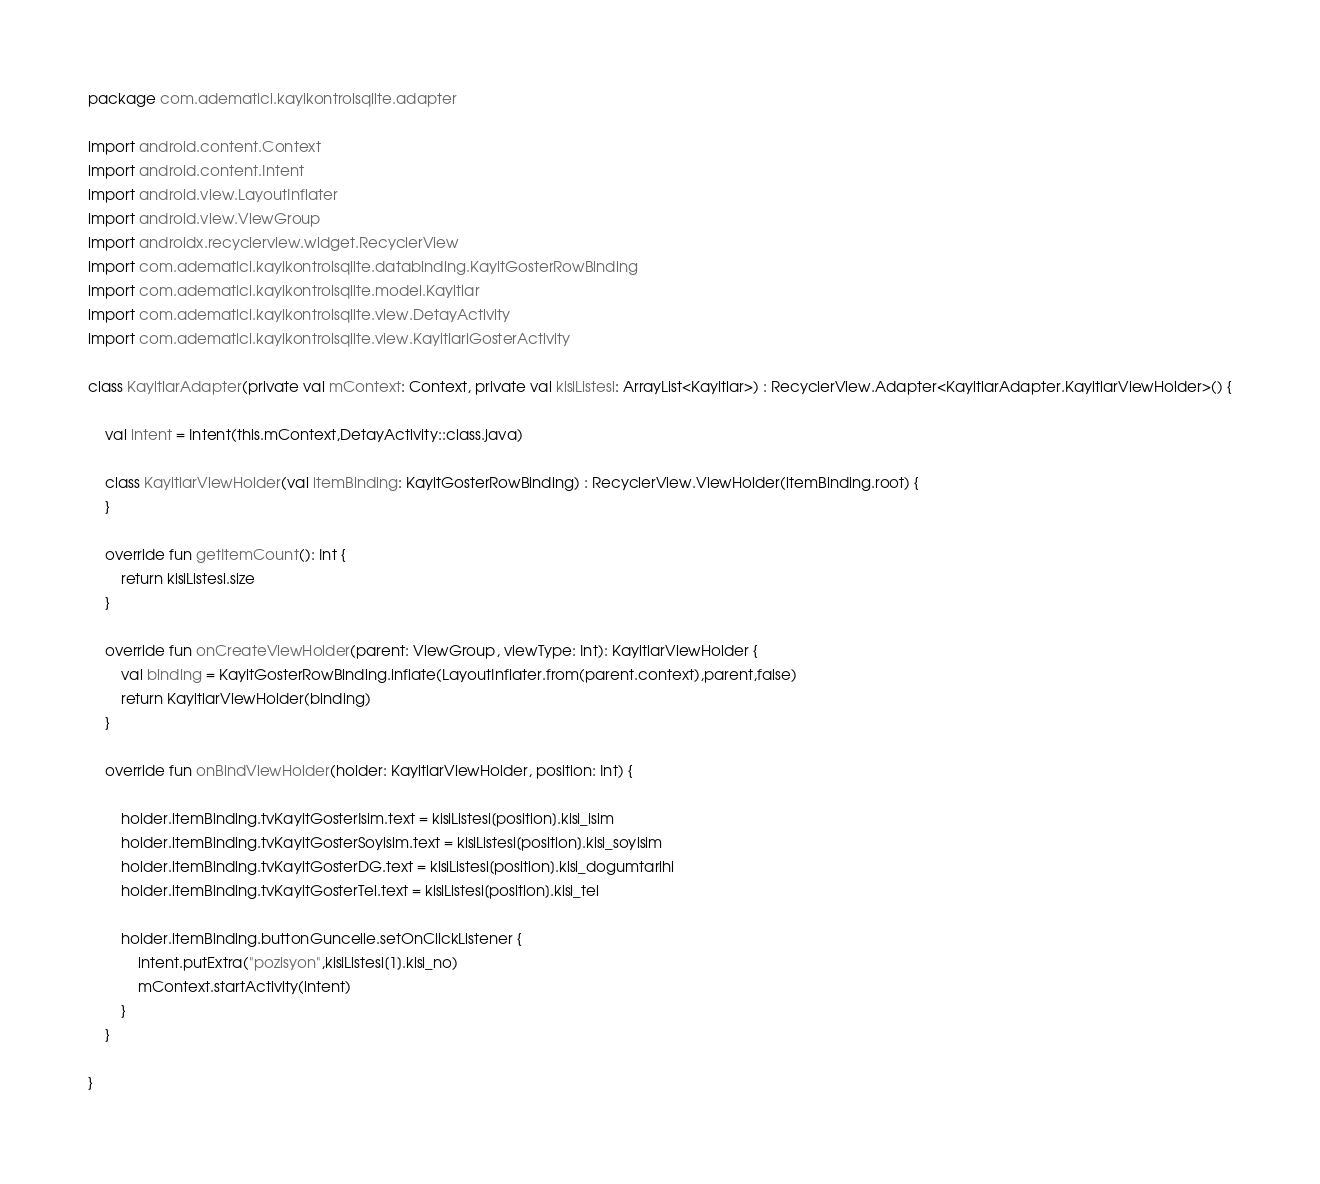<code> <loc_0><loc_0><loc_500><loc_500><_Kotlin_>package com.adematici.kayikontrolsqlite.adapter

import android.content.Context
import android.content.Intent
import android.view.LayoutInflater
import android.view.ViewGroup
import androidx.recyclerview.widget.RecyclerView
import com.adematici.kayikontrolsqlite.databinding.KayitGosterRowBinding
import com.adematici.kayikontrolsqlite.model.Kayitlar
import com.adematici.kayikontrolsqlite.view.DetayActivity
import com.adematici.kayikontrolsqlite.view.KayitlariGosterActivity

class KayitlarAdapter(private val mContext: Context, private val kisiListesi: ArrayList<Kayitlar>) : RecyclerView.Adapter<KayitlarAdapter.KayitlarViewHolder>() {

    val intent = Intent(this.mContext,DetayActivity::class.java)

    class KayitlarViewHolder(val itemBinding: KayitGosterRowBinding) : RecyclerView.ViewHolder(itemBinding.root) {
    }

    override fun getItemCount(): Int {
        return kisiListesi.size
    }

    override fun onCreateViewHolder(parent: ViewGroup, viewType: Int): KayitlarViewHolder {
        val binding = KayitGosterRowBinding.inflate(LayoutInflater.from(parent.context),parent,false)
        return KayitlarViewHolder(binding)
    }

    override fun onBindViewHolder(holder: KayitlarViewHolder, position: Int) {

        holder.itemBinding.tvKayitGosterIsim.text = kisiListesi[position].kisi_isim
        holder.itemBinding.tvKayitGosterSoyisim.text = kisiListesi[position].kisi_soyisim
        holder.itemBinding.tvKayitGosterDG.text = kisiListesi[position].kisi_dogumtarihi
        holder.itemBinding.tvKayitGosterTel.text = kisiListesi[position].kisi_tel

        holder.itemBinding.buttonGuncelle.setOnClickListener {
            intent.putExtra("pozisyon",kisiListesi[1].kisi_no)
            mContext.startActivity(intent)
        }
    }

}</code> 